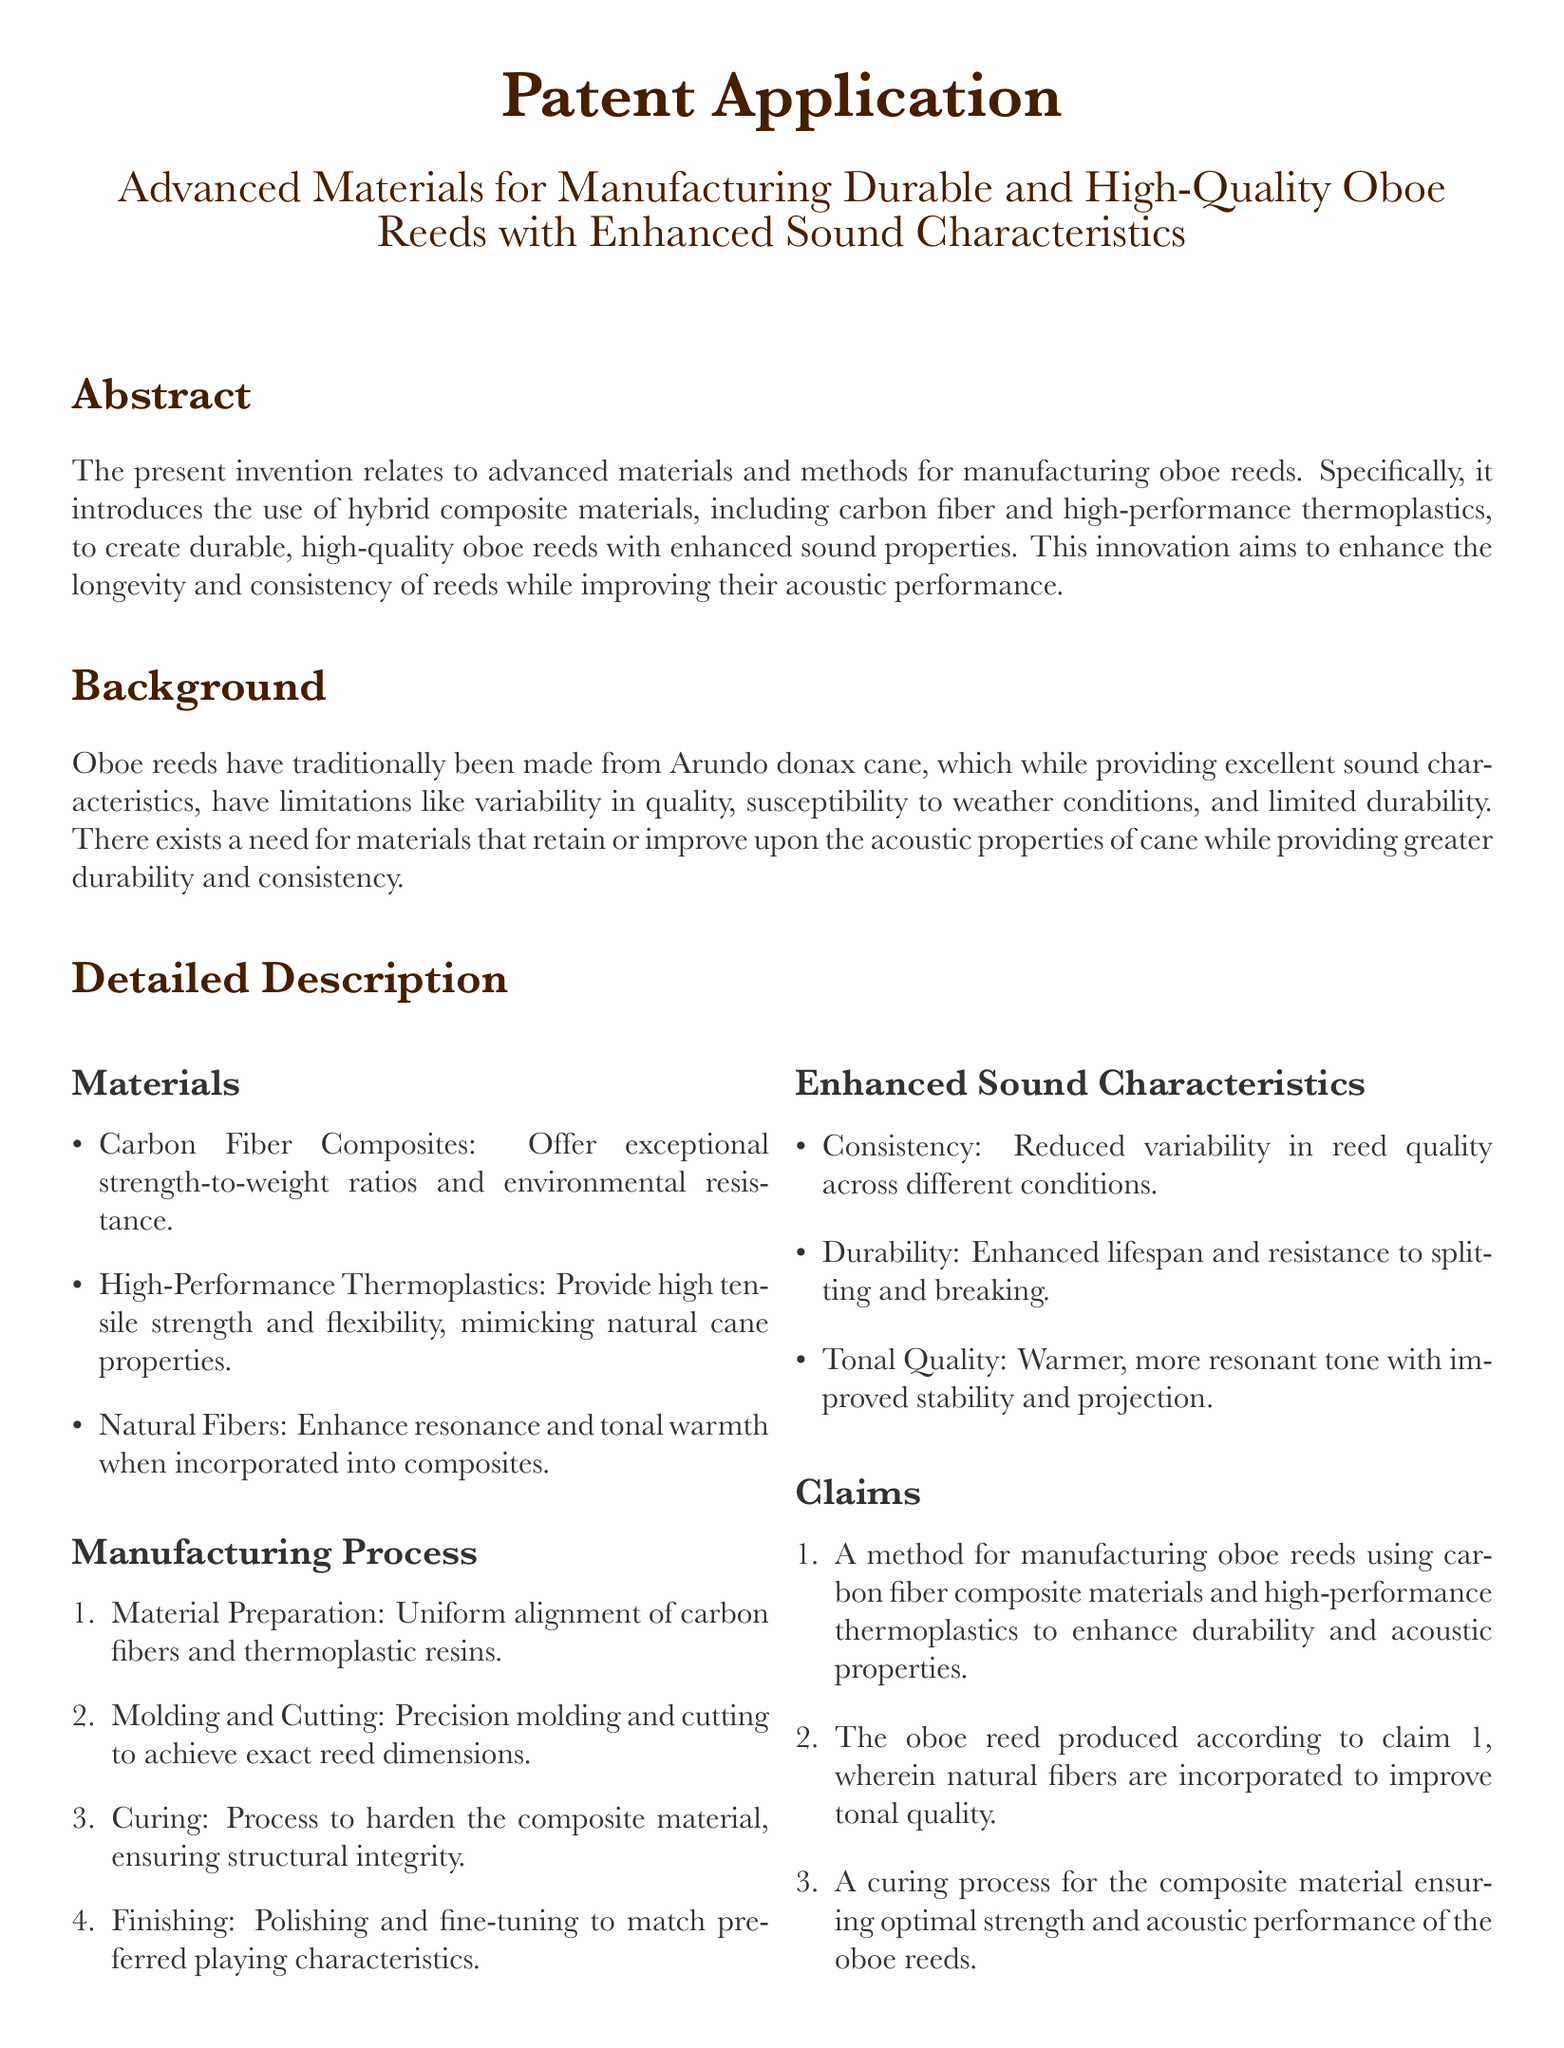what is the main focus of the patent application? The patent application focuses on advanced materials and methods for manufacturing oboe reeds.
Answer: advanced materials and methods for manufacturing oboe reeds which materials are highlighted for their use in oboe reed manufacturing? The patent application specifically mentions carbon fiber composites and high-performance thermoplastics as the materials used.
Answer: carbon fiber composites and high-performance thermoplastics what is one benefit of using natural fibers in the composite materials? Natural fibers are noted to enhance resonance and tonal warmth when incorporated into the composites.
Answer: enhance resonance and tonal warmth how many steps are there in the manufacturing process described? The document outlines a four-step manufacturing process for the oboe reeds.
Answer: four what is a key characteristic of the oboe reeds produced according to claim 1? The reeds manufactured according to claim 1 are meant to enhance durability and acoustic properties.
Answer: durability and acoustic properties what is the purpose of the curing process mentioned in the document? The curing process is designed to ensure optimal strength and acoustic performance of the oboe reeds.
Answer: optimal strength and acoustic performance how does the invention aim to improve the consistency of reeds? The invention aims to reduce variability in reed quality across different conditions.
Answer: reduce variability which cane is traditionally used for making oboe reeds? The document states that Arundo donax cane is traditionally used for making oboe reeds.
Answer: Arundo donax cane 